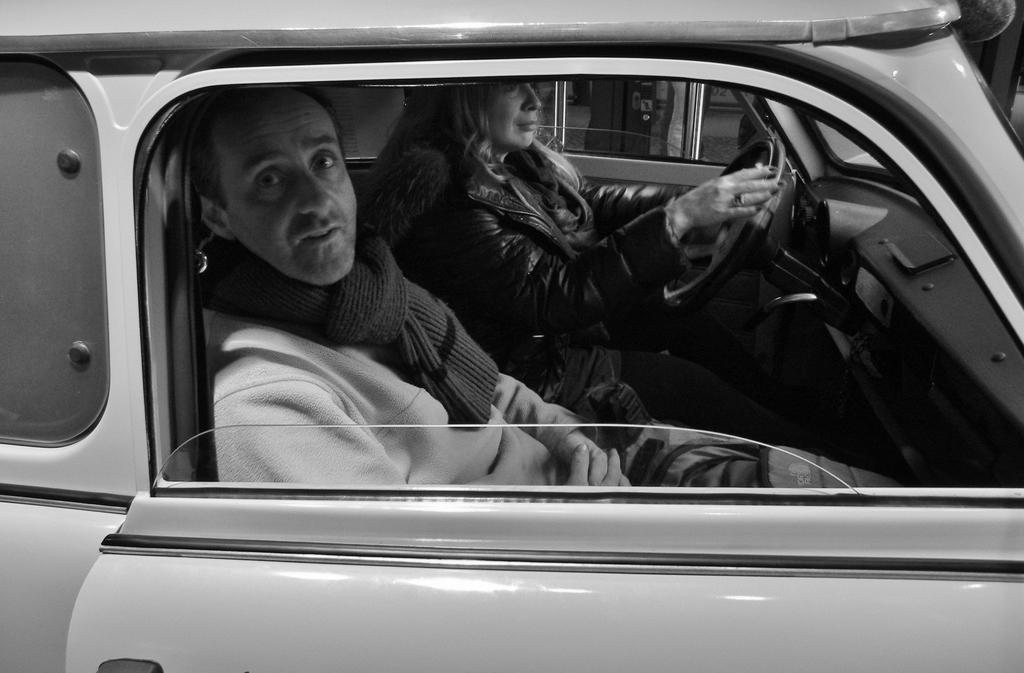In one or two sentences, can you explain what this image depicts? In this image there is a vehicle in which a person is sitting beside the window of the vehicle. Woman sitting beside this person is holding steering of the vehicle. 